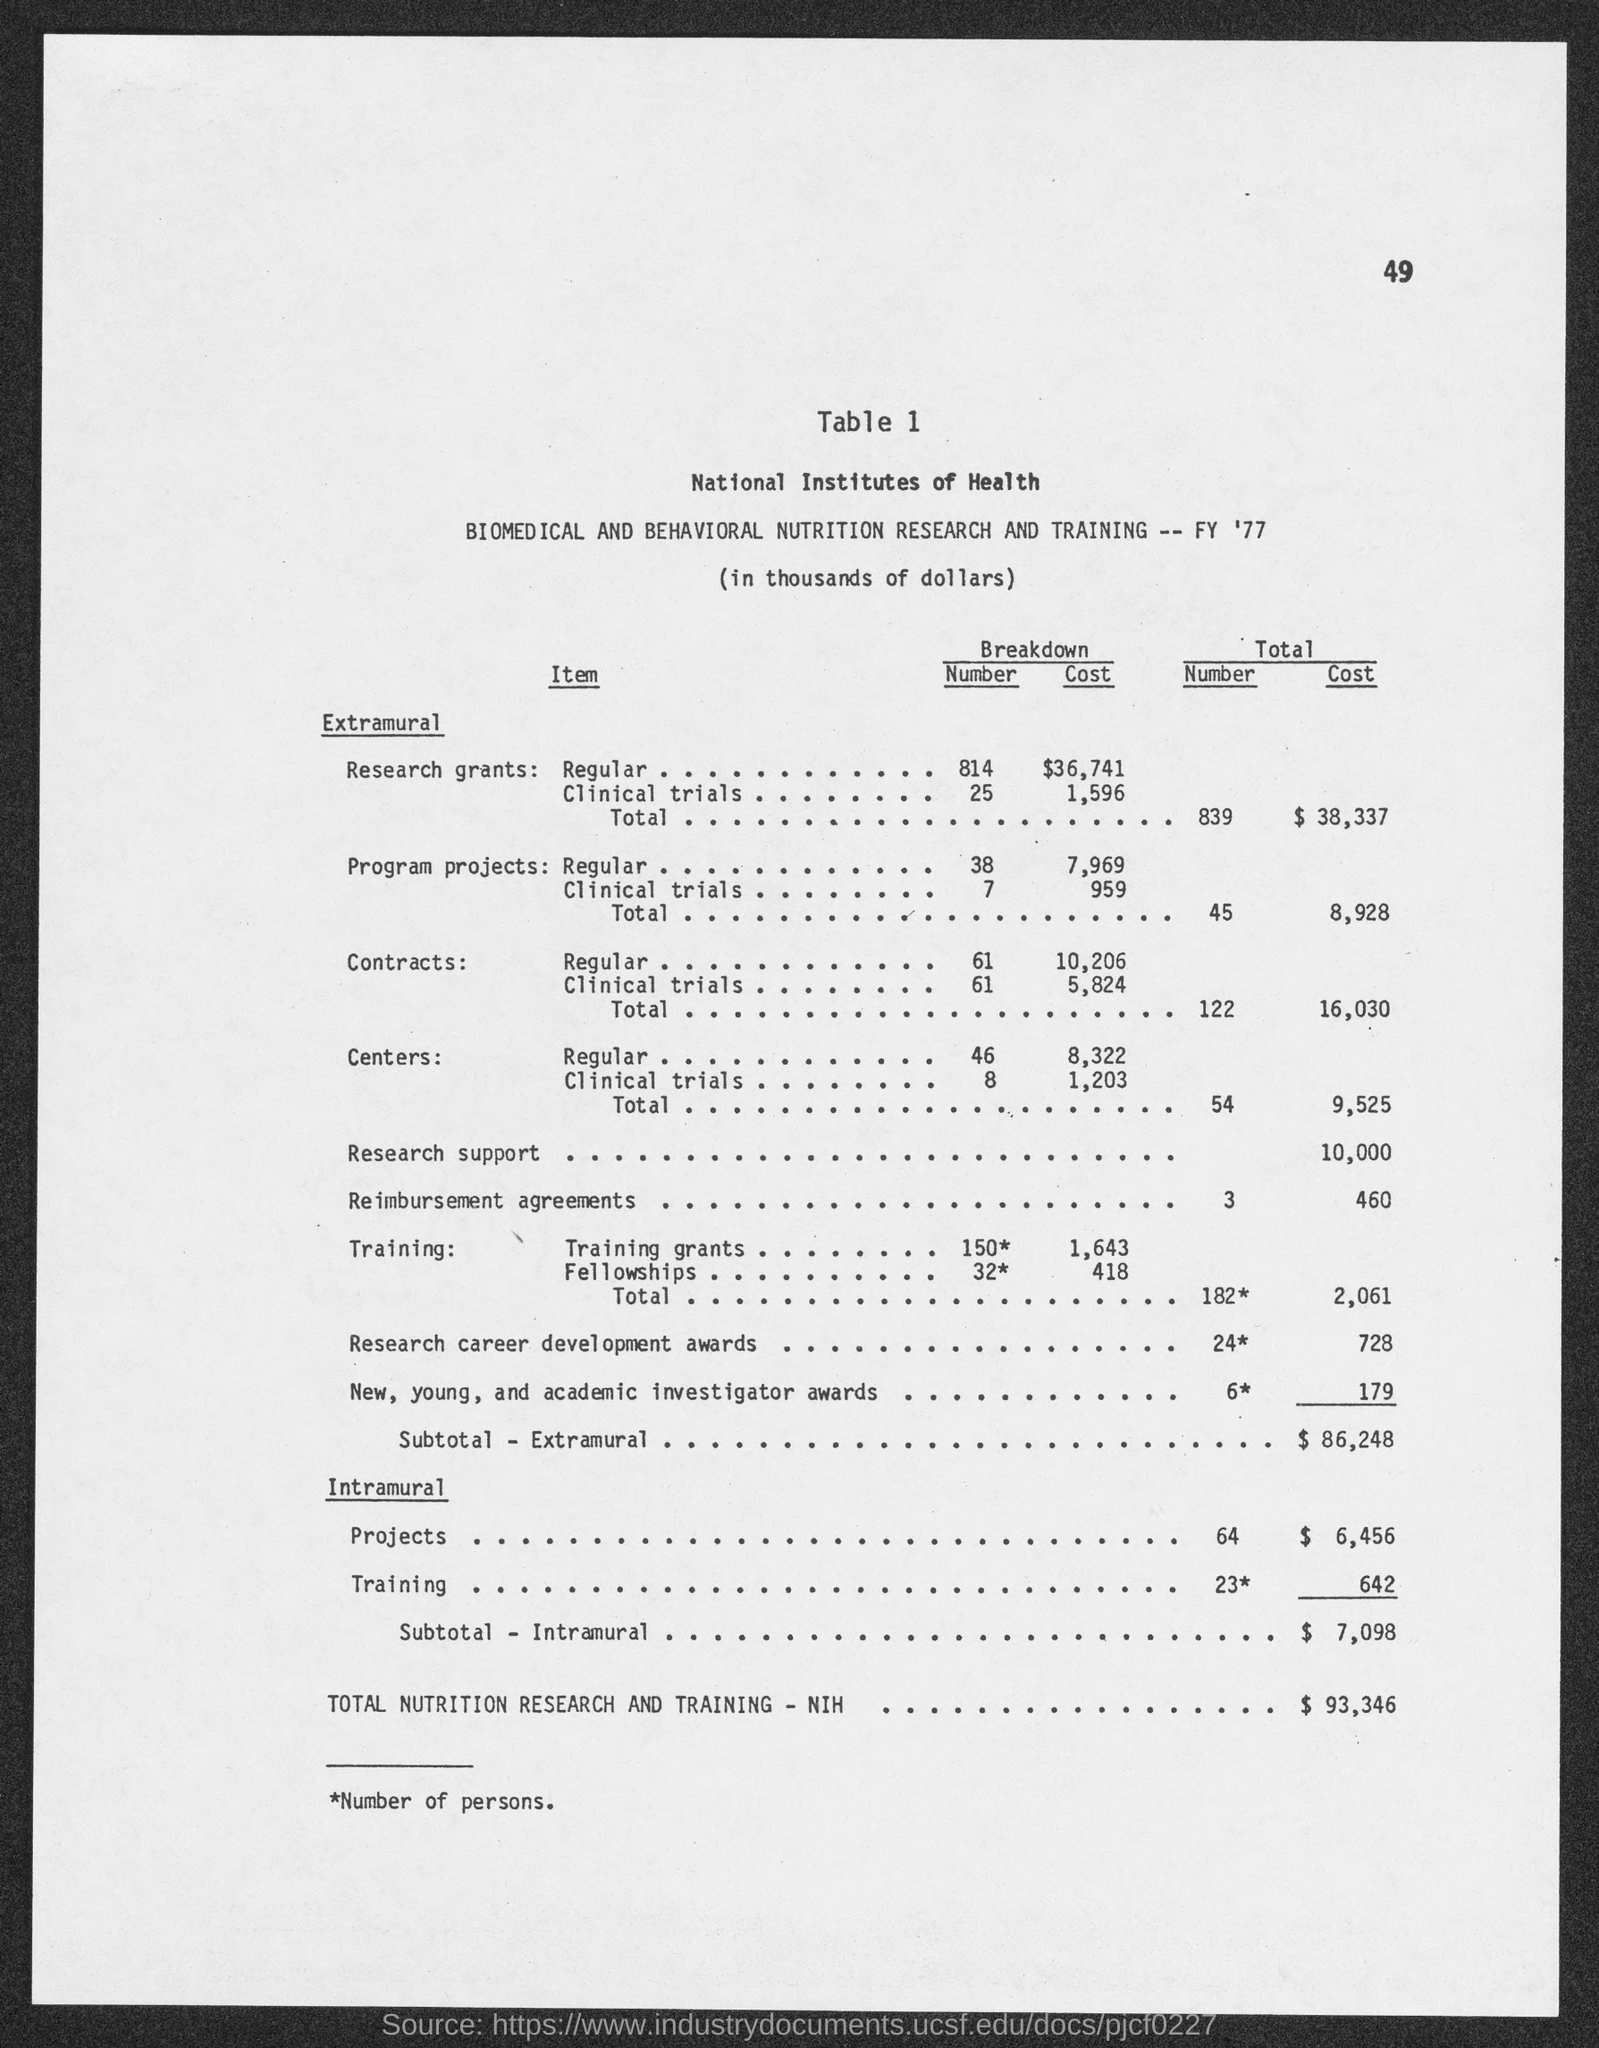What is the page number at top of the page?
Your answer should be compact. 49. What is the total cost of research grants?
Make the answer very short. $38,337. What is the total cost of program projects ?
Keep it short and to the point. $8,928. What is the total cost of contracts ?
Ensure brevity in your answer.  $16,030. What is the total cost of centers ?
Your response must be concise. $9,525. What is the total cost of research support ?
Your answer should be compact. $10,000. What is the total cost of reimbursement agreements ?
Provide a short and direct response. $460. What is the subtotal cost of extramural ?
Offer a terse response. $86,248. What is the subtotal of intramural ?
Give a very brief answer. $ 7,098. What is the total nutrition research and training - nih cost ?
Your answer should be compact. $93,346. 